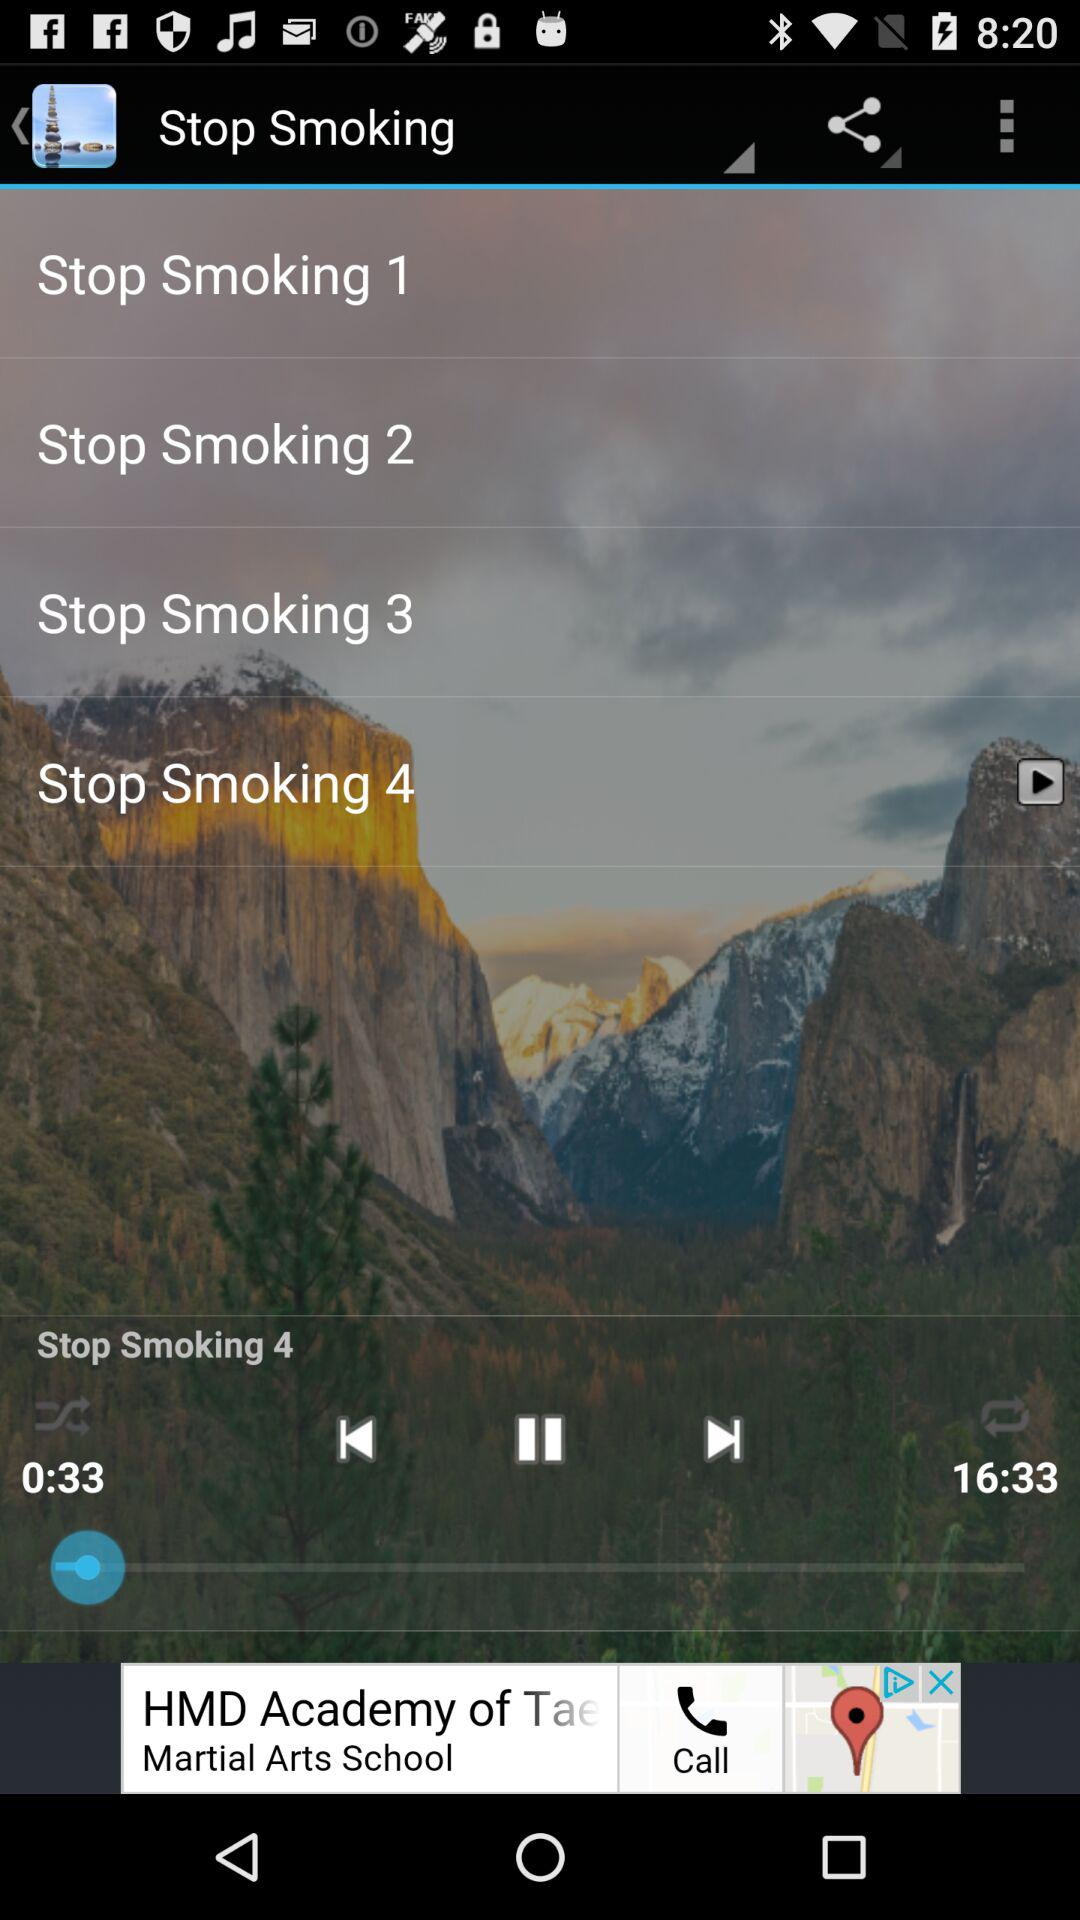What is the duration of the track? The duration of the track is 16 minutes 33 seconds. 